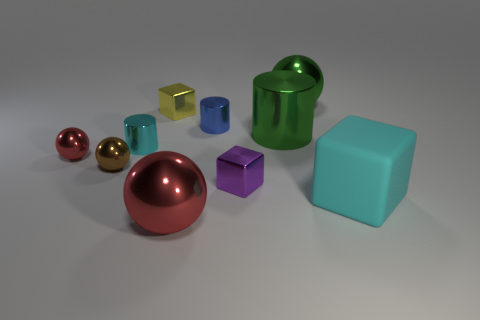Subtract all cylinders. How many objects are left? 7 Add 5 big green metallic spheres. How many big green metallic spheres are left? 6 Add 3 yellow matte things. How many yellow matte things exist? 3 Subtract 1 green cylinders. How many objects are left? 9 Subtract all small brown metallic things. Subtract all green shiny cylinders. How many objects are left? 8 